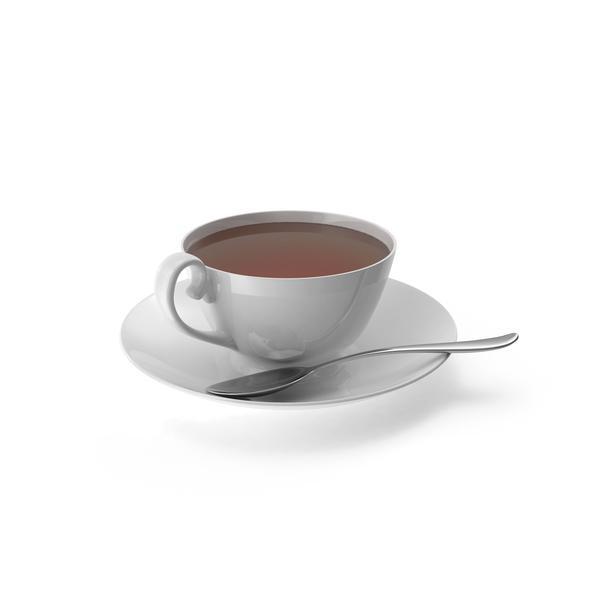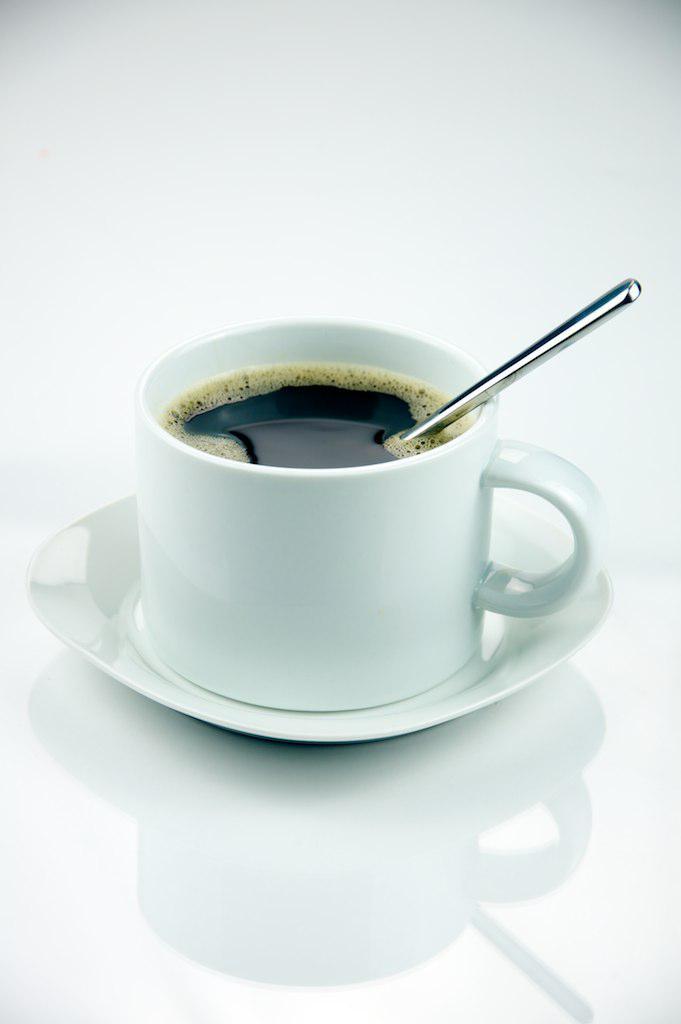The first image is the image on the left, the second image is the image on the right. Examine the images to the left and right. Is the description "There is a spoon in at least one teacup" accurate? Answer yes or no. Yes. The first image is the image on the left, the second image is the image on the right. Considering the images on both sides, is "The handle of a utensil sticks out of a cup of coffee in at least one image." valid? Answer yes or no. Yes. 